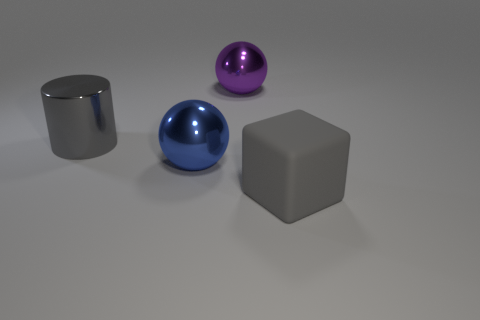How many large brown objects are made of the same material as the large purple sphere? In the image, there are no large brown objects present at all. There are three objects with reflective surfaces that appear similar in material to the large purple sphere – a large blue sphere, a silver cylinder, and a grey cube. 